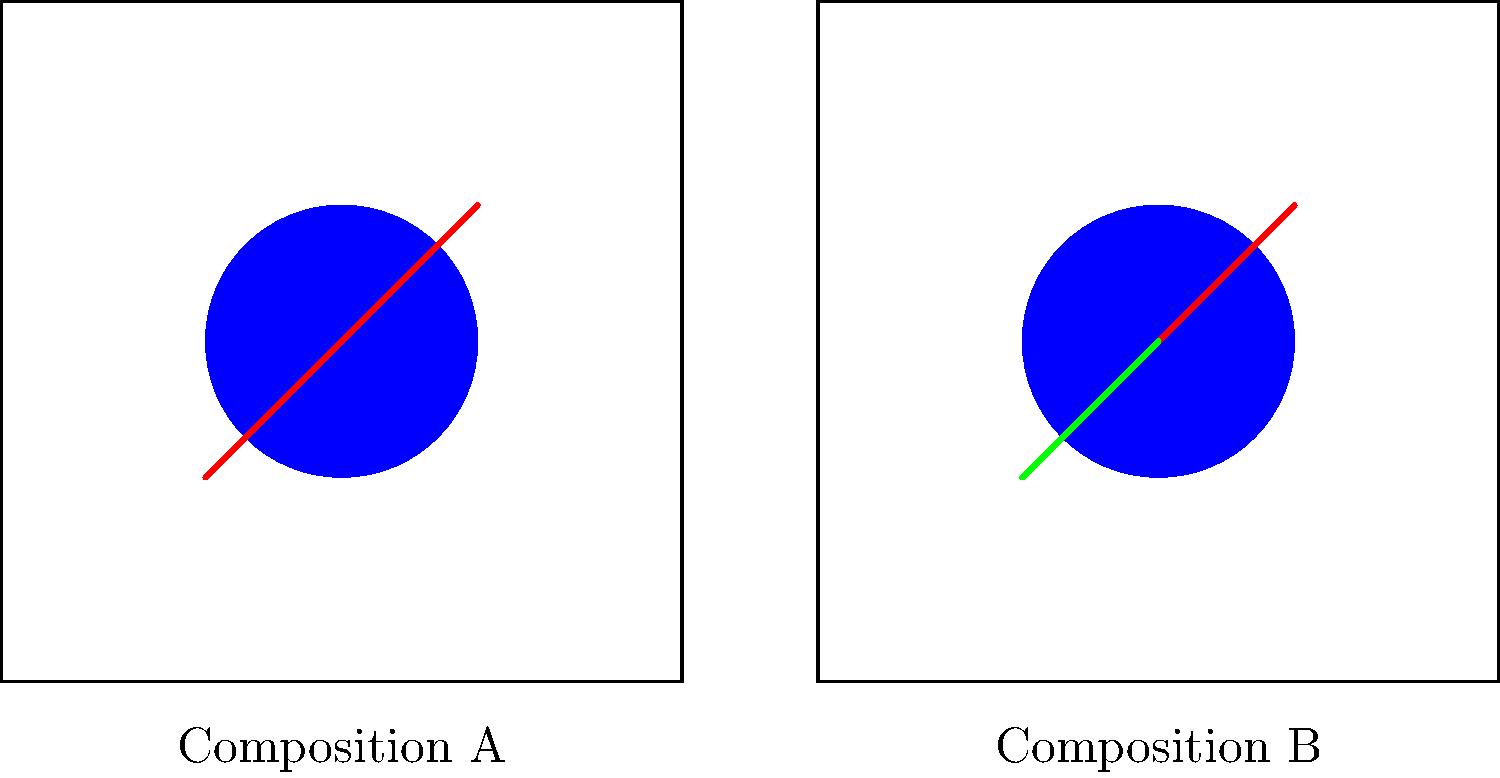In the two 'The Tick' artwork compositions shown above, how many differences can you identify between Composition A and Composition B? To identify the differences between the two compositions, let's analyze them step by step:

1. Overall structure: Both compositions have a square frame with a blue circle in the center. This is the same in both.

2. Blue circle: The blue circles appear to be the same size and position in both compositions. No difference here.

3. Red lines:
   - In Composition A, there are two red lines extending from the center of the circle, one to the top-right and one to the bottom-left.
   - In Composition B, there is only one red line, extending from the center to the top-right.
   - This is the first difference.

4. Green line:
   - In Composition A, there is no green line.
   - In Composition B, there is a green line extending from the center to the bottom-left.
   - This is the second difference.

In total, we can identify two differences between the compositions:
1. The missing red line in Composition B
2. The additional green line in Composition B

These differences could represent variations in The Tick's antennae or other stylistic elements in the custom artwork.
Answer: 2 